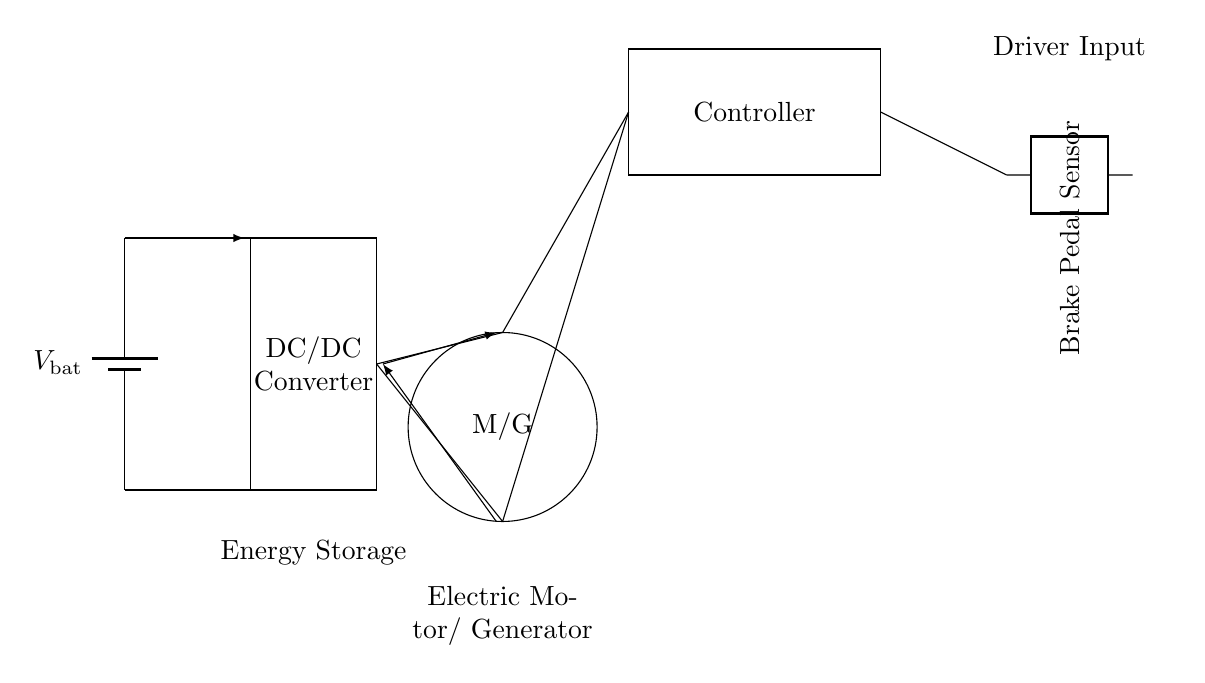What is the voltage source present in the circuit? The circuit includes a battery, identified as the voltage source with the label V_bat. This is the component providing electrical energy for the circuit.
Answer: V_bat What component is represented by the circle in the diagram? The symbol for the circular component indicates a motor or generator, labeled M/G. This implies that it can function as either a motor for propulsion or as a generator during regenerative braking to recover energy.
Answer: M/G How is the brake pedal sensor shown in the circuit? The brake pedal sensor is represented by a two-port component connected to the controller, indicating its role in sensing the brake input and providing feedback for control processes.
Answer: Brake Pedal Sensor What is the function of the DC/DC converter in this circuit? The DC/DC converter is designated as a rectangular block between the battery and the motor/generator. It serves to regulate and convert voltage levels for efficient operation, enabling proper voltage supply to the motor/generator.
Answer: Regulating voltage Which component connects the energy storage to the motor/generator? The connection between the energy storage (battery) and the motor/generator involves two paths: one for the normal operation and the other for energy recovery, indicating the dual function of this system during braking.
Answer: Connections How does the controller interact with other components? The controller receives input from the brake pedal sensor, processes this information, and then affects the operation of both the motor/generator and the DC/DC converter, thereby facilitating energy recovery during braking and energy management overall.
Answer: Controller interaction What is the main purpose of regenerative braking in this circuit? The primary purpose of regenerative braking is to capture kinetic energy during vehicle deceleration and convert it into electrical energy, which can then be stored back in the energy storage system, improving overall vehicle efficiency and reducing energy loss.
Answer: Energy recovery 